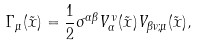Convert formula to latex. <formula><loc_0><loc_0><loc_500><loc_500>\Gamma _ { \mu } ( \tilde { x } ) = \frac { 1 } { 2 } \sigma ^ { \alpha \beta } V _ { \alpha } ^ { \, \nu } ( \tilde { x } ) V _ { \beta \nu ; \mu } ( \tilde { x } ) ,</formula> 